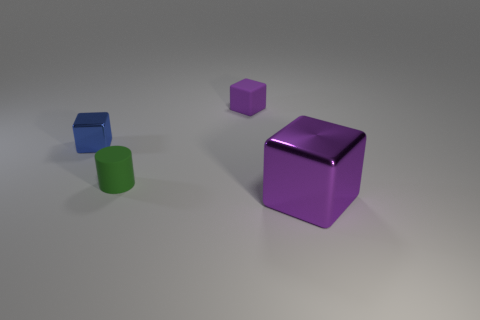Add 4 purple things. How many objects exist? 8 Subtract all blocks. How many objects are left? 1 Subtract all big cyan cubes. Subtract all tiny metallic objects. How many objects are left? 3 Add 2 purple metallic cubes. How many purple metallic cubes are left? 3 Add 3 tiny purple blocks. How many tiny purple blocks exist? 4 Subtract 1 blue cubes. How many objects are left? 3 